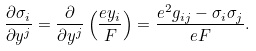<formula> <loc_0><loc_0><loc_500><loc_500>\frac { \partial \sigma _ { i } } { \partial y ^ { j } } = \frac { \partial } { \partial y ^ { j } } \left ( \frac { e y _ { i } } { F } \right ) = \frac { e ^ { 2 } g _ { i j } - \sigma _ { i } \sigma _ { j } } { e F } .</formula> 